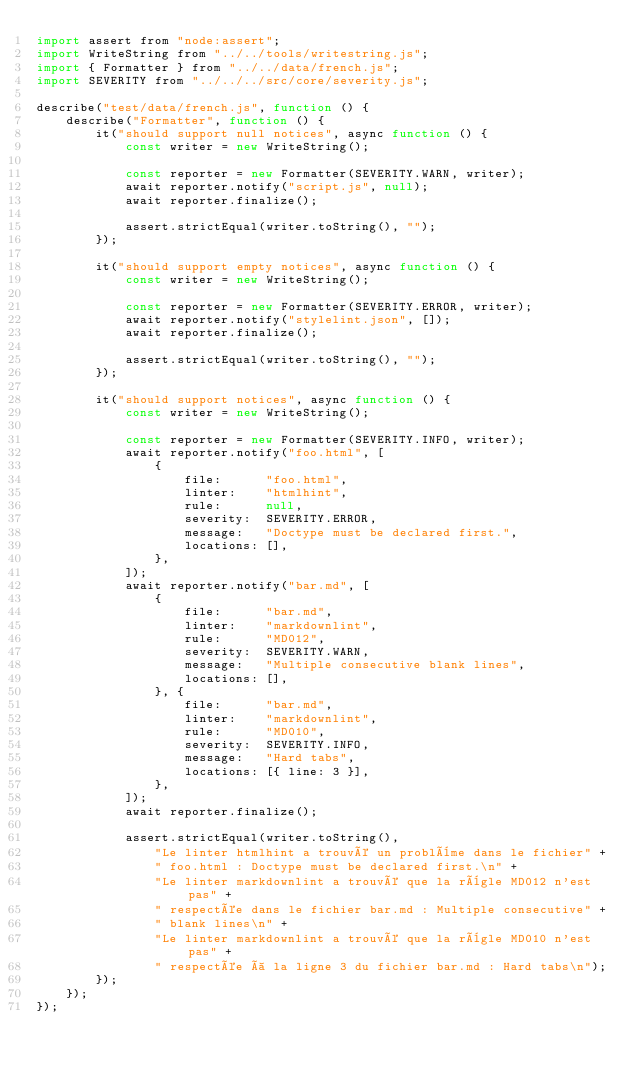Convert code to text. <code><loc_0><loc_0><loc_500><loc_500><_JavaScript_>import assert from "node:assert";
import WriteString from "../../tools/writestring.js";
import { Formatter } from "../../data/french.js";
import SEVERITY from "../../../src/core/severity.js";

describe("test/data/french.js", function () {
    describe("Formatter", function () {
        it("should support null notices", async function () {
            const writer = new WriteString();

            const reporter = new Formatter(SEVERITY.WARN, writer);
            await reporter.notify("script.js", null);
            await reporter.finalize();

            assert.strictEqual(writer.toString(), "");
        });

        it("should support empty notices", async function () {
            const writer = new WriteString();

            const reporter = new Formatter(SEVERITY.ERROR, writer);
            await reporter.notify("stylelint.json", []);
            await reporter.finalize();

            assert.strictEqual(writer.toString(), "");
        });

        it("should support notices", async function () {
            const writer = new WriteString();

            const reporter = new Formatter(SEVERITY.INFO, writer);
            await reporter.notify("foo.html", [
                {
                    file:      "foo.html",
                    linter:    "htmlhint",
                    rule:      null,
                    severity:  SEVERITY.ERROR,
                    message:   "Doctype must be declared first.",
                    locations: [],
                },
            ]);
            await reporter.notify("bar.md", [
                {
                    file:      "bar.md",
                    linter:    "markdownlint",
                    rule:      "MD012",
                    severity:  SEVERITY.WARN,
                    message:   "Multiple consecutive blank lines",
                    locations: [],
                }, {
                    file:      "bar.md",
                    linter:    "markdownlint",
                    rule:      "MD010",
                    severity:  SEVERITY.INFO,
                    message:   "Hard tabs",
                    locations: [{ line: 3 }],
                },
            ]);
            await reporter.finalize();

            assert.strictEqual(writer.toString(),
                "Le linter htmlhint a trouvé un problème dans le fichier" +
                " foo.html : Doctype must be declared first.\n" +
                "Le linter markdownlint a trouvé que la règle MD012 n'est pas" +
                " respectée dans le fichier bar.md : Multiple consecutive" +
                " blank lines\n" +
                "Le linter markdownlint a trouvé que la règle MD010 n'est pas" +
                " respectée à la ligne 3 du fichier bar.md : Hard tabs\n");
        });
    });
});
</code> 